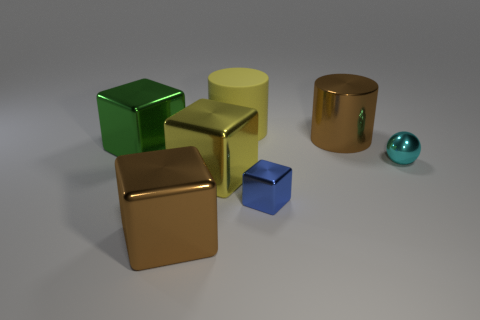How many objects are either cubes on the left side of the yellow cylinder or big metallic blocks right of the green object?
Your response must be concise. 3. There is a blue block behind the brown shiny object in front of the shiny cube right of the large yellow matte cylinder; what size is it?
Provide a short and direct response. Small. Is the number of brown objects that are on the left side of the yellow cylinder the same as the number of big cyan metallic blocks?
Offer a very short reply. No. Are there any other things that are the same shape as the tiny cyan metallic object?
Give a very brief answer. No. Does the yellow matte object have the same shape as the big brown metallic thing that is behind the green shiny block?
Give a very brief answer. Yes. What size is the other brown thing that is the same shape as the large rubber thing?
Ensure brevity in your answer.  Large. How many other things are there of the same material as the big yellow cylinder?
Offer a terse response. 0. What is the tiny blue cube made of?
Ensure brevity in your answer.  Metal. Is the color of the large metal thing in front of the small shiny block the same as the large metallic thing right of the rubber object?
Keep it short and to the point. Yes. Is the number of shiny things behind the ball greater than the number of small blue shiny objects?
Your answer should be very brief. Yes. 